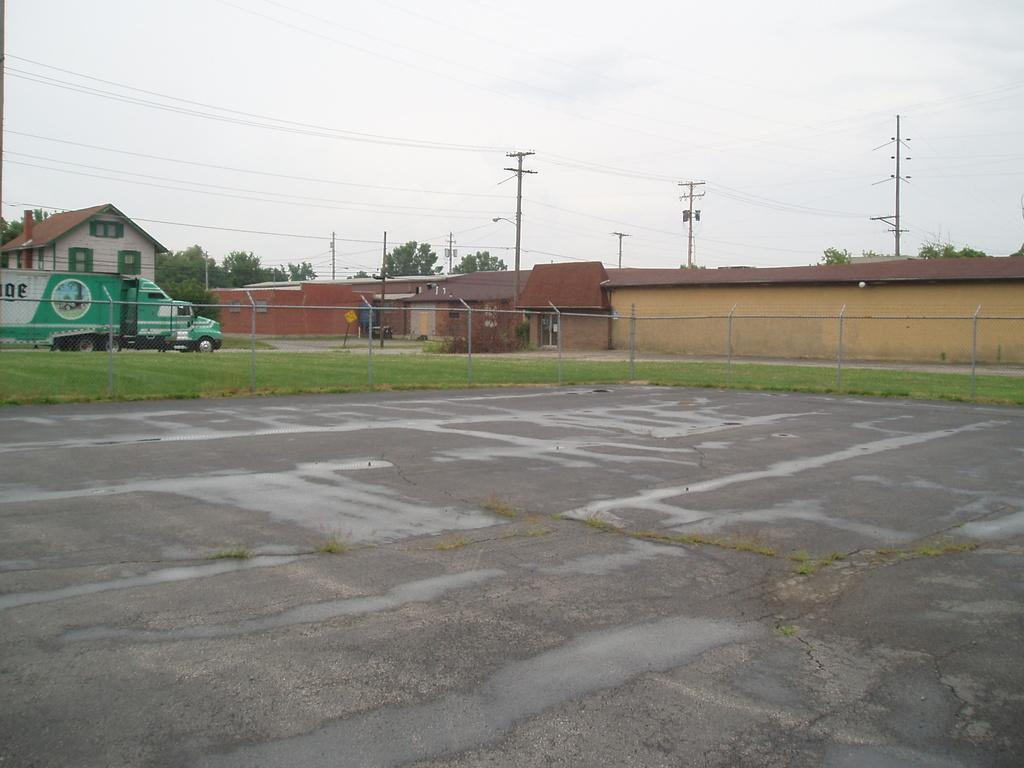What type of surface can be seen in the image? There is a road in the image. What is located near the road? There is a fence in the image. What type of vegetation is present on the ground? Grass is present on the ground. What structures are visible in the image? There are electric poles and houses in the image. What part of the houses can be seen? Windows are visible in the image. What is connected to the electric poles? Wires are present in the image. What type of natural elements can be seen in the image? Trees are visible in the image. What is attached to a pole in the image? There is a board on a pole in the image. What is visible in the sky? Clouds are visible in the sky. How many sisters are sitting on the rock in the image? There is no rock or sisters present in the image. What type of comfort can be seen in the image? The image does not depict any comfort or comfort-related items. 